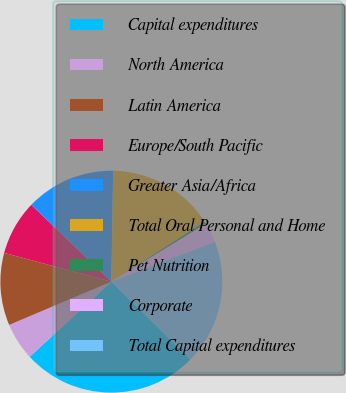Convert chart to OTSL. <chart><loc_0><loc_0><loc_500><loc_500><pie_chart><fcel>Capital expenditures<fcel>North America<fcel>Latin America<fcel>Europe/South Pacific<fcel>Greater Asia/Africa<fcel>Total Oral Personal and Home<fcel>Pet Nutrition<fcel>Corporate<fcel>Total Capital expenditures<nl><fcel>25.81%<fcel>5.46%<fcel>10.55%<fcel>8.0%<fcel>13.09%<fcel>15.63%<fcel>0.37%<fcel>2.91%<fcel>18.18%<nl></chart> 